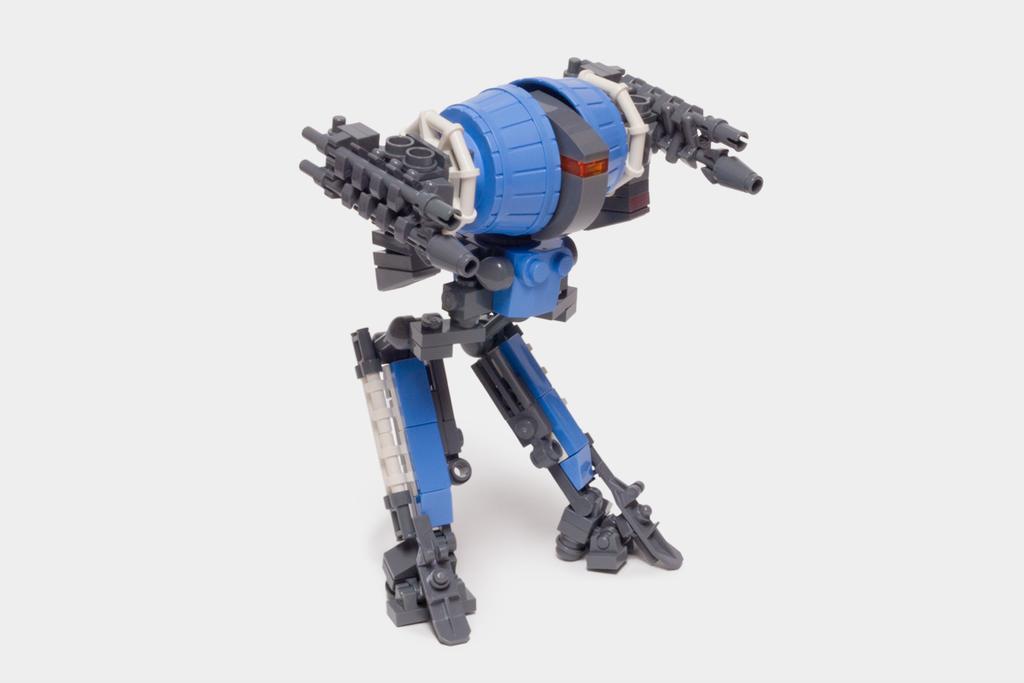Could you give a brief overview of what you see in this image? In this image, we can see a Lego toy and there is white background. 